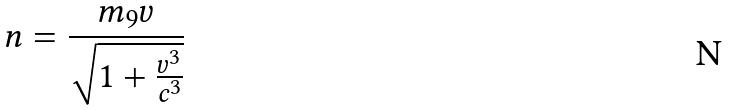<formula> <loc_0><loc_0><loc_500><loc_500>n = \frac { m _ { 9 } v } { \sqrt { 1 + \frac { v ^ { 3 } } { c ^ { 3 } } } }</formula> 